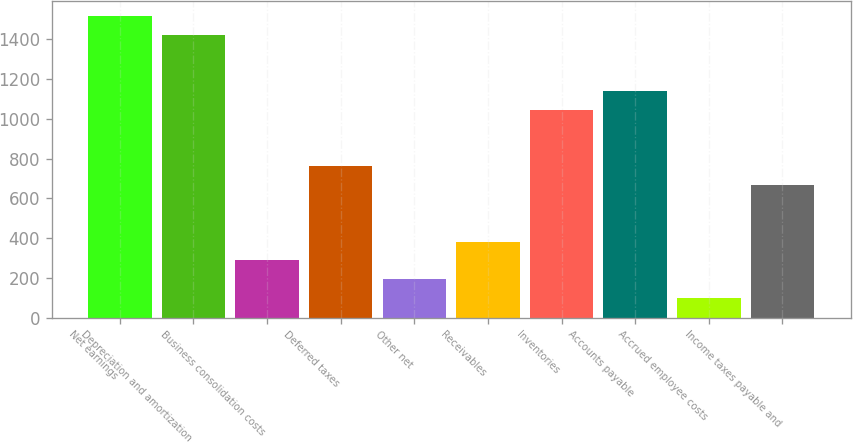Convert chart to OTSL. <chart><loc_0><loc_0><loc_500><loc_500><bar_chart><fcel>Net earnings<fcel>Depreciation and amortization<fcel>Business consolidation costs<fcel>Deferred taxes<fcel>Other net<fcel>Receivables<fcel>Inventories<fcel>Accounts payable<fcel>Accrued employee costs<fcel>Income taxes payable and<nl><fcel>1517<fcel>1422.45<fcel>287.85<fcel>760.6<fcel>193.3<fcel>382.4<fcel>1044.25<fcel>1138.8<fcel>98.75<fcel>666.05<nl></chart> 